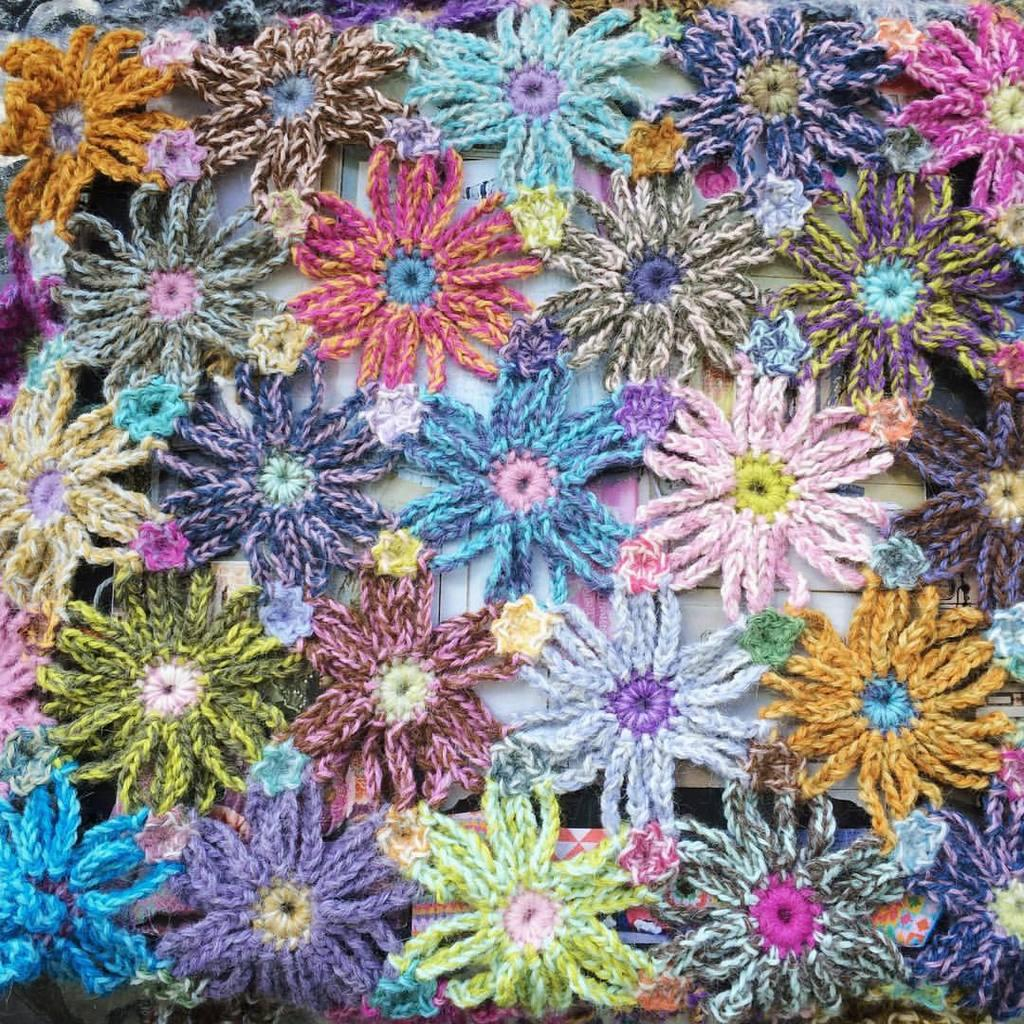What type of flowers are depicted in the image? There are woolen flowers in the image. What type of medical facility is shown in the image? There is no medical facility or hospital present in the image; it only features woolen flowers. What type of farming equipment is being used in the image? There is no farming equipment or yoke present in the image; it only features woolen flowers. 